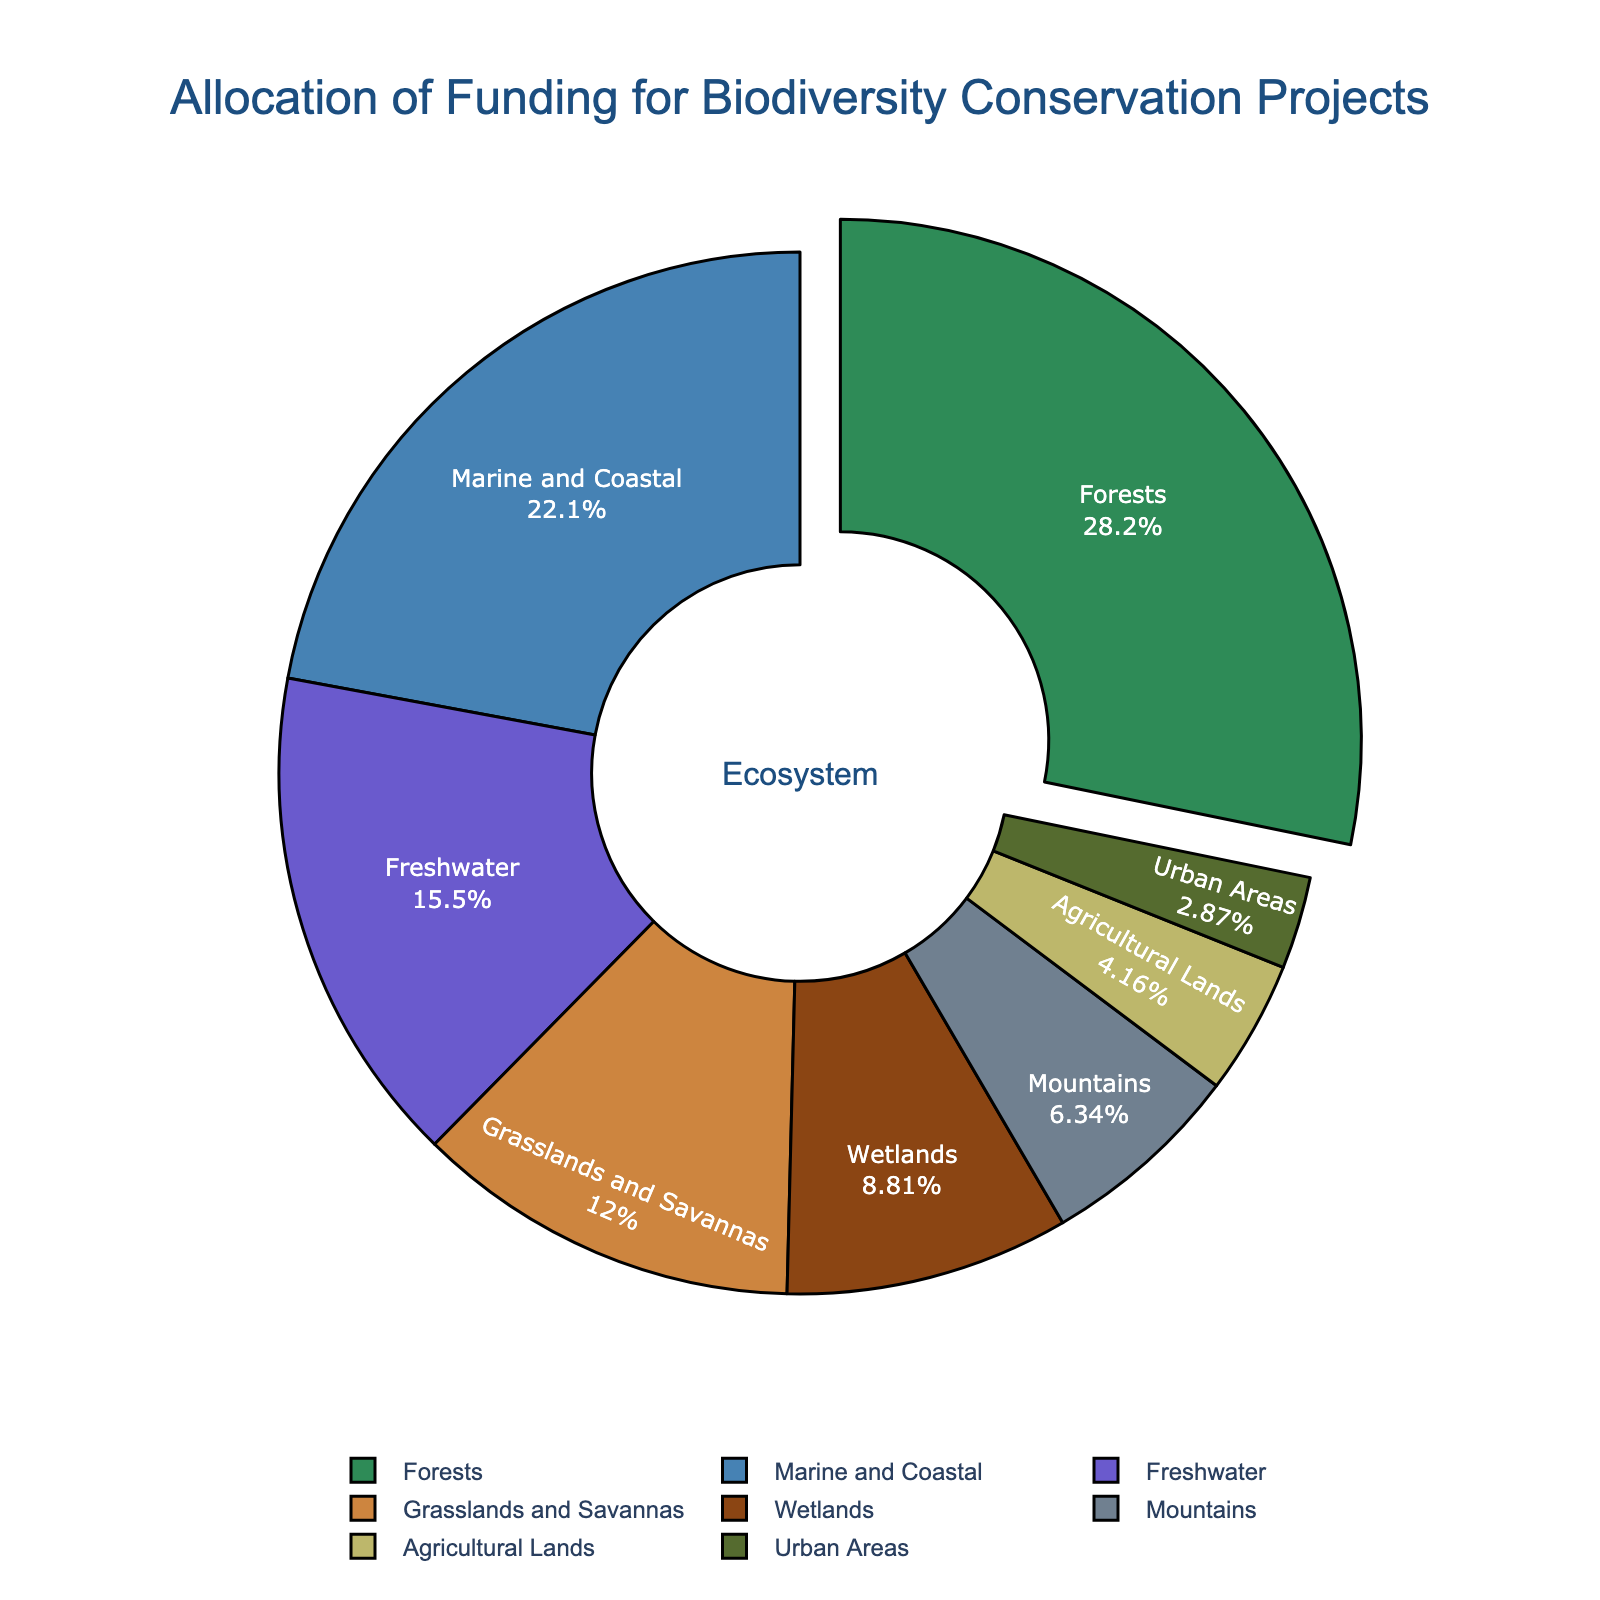Which ecosystem receives the highest percentage of funding? The highest percentage of funding is visually highlighted by being slightly pulled out from the pie chart. This is the ecosystem with the highest funding percentage.
Answer: Forests What is the total percentage of funding allocated to Marine and Coastal and Grasslands and Savannas ecosystems? Sum the percentages allocated to Marine and Coastal (22.3%) and Grasslands and Savannas (12.1%). Mathematically, 22.3 + 12.1 = 34.4.
Answer: 34.4% Which ecosystems receive less funding than Freshwater ecosystems? By comparing the percentage values, we see that Wetlands (8.9%), Mountains (6.4%), Agricultural Lands (4.2%), and Urban Areas (2.9%) have lower funding percentages than Freshwater (15.7%).
Answer: Wetlands, Mountains, Agricultural Lands, Urban Areas How much more funding (in percentage points) do Forests receive compared to Wetlands? Subtract Wetlands' percentage (8.9%) from Forests’ percentage (28.5%): 28.5 - 8.9 = 19.6
Answer: 19.6 What percentage of funding is allocated to ecosystems other than Forests and Marine and Coastal? Subtract the sum of Forests (28.5%) and Marine and Coastal (22.3%) from 100%: 100 - (28.5 + 22.3) = 49.2
Answer: 49.2% Which ecosystem has the smallest share of the funding? Identify the ecosystem with the lowest percentage in the pie chart. This is visually the smallest segment.
Answer: Urban Areas What is the average funding percentage allocated to Mountains, Agricultural Lands, and Urban Areas? Sum the percentages for Mountains (6.4%), Agricultural Lands (4.2%), and Urban Areas (2.9%) and then divide by 3: (6.4 + 4.2 + 2.9) / 3 = 4.5 (approx)
Answer: 4.5% How does the funding for Agricultural Lands compare to Grasslands and Savannas in terms of percentage difference? Calculate the percentage difference between Grasslands and Savannas (12.1%) and Agricultural Lands (4.2%) by subtracting the smaller from the larger: 12.1 - 4.2 = 7.9
Answer: 7.9% Which color represents the Marine and Coastal ecosystems in the pie chart? In the pie chart, the Marine and Coastal segment is represented in blue, which corresponds to the color allocation.
Answer: Blue How much funding (in percentage points) separates the ecosystem with the second-highest funding from the third-highest? Identify the second-highest (Marine and Coastal, 22.3%) and third-highest (Freshwater, 15.7%) funding percentages, and subtract the latter from the former: 22.3 - 15.7 = 6.6
Answer: 6.6 